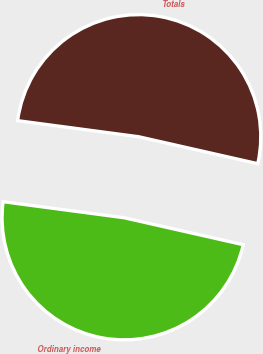<chart> <loc_0><loc_0><loc_500><loc_500><pie_chart><fcel>Ordinary income<fcel>Totals<nl><fcel>48.56%<fcel>51.44%<nl></chart> 